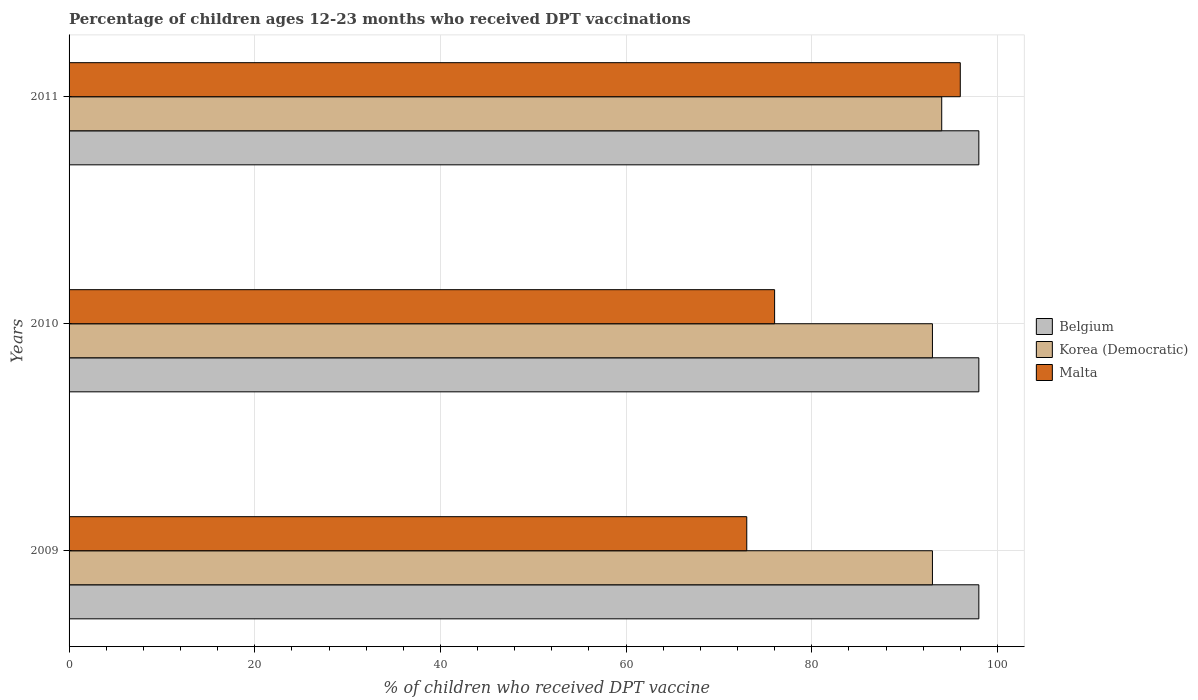How many different coloured bars are there?
Give a very brief answer. 3. How many groups of bars are there?
Offer a very short reply. 3. Are the number of bars per tick equal to the number of legend labels?
Ensure brevity in your answer.  Yes. How many bars are there on the 3rd tick from the bottom?
Make the answer very short. 3. What is the label of the 1st group of bars from the top?
Offer a very short reply. 2011. Across all years, what is the maximum percentage of children who received DPT vaccination in Malta?
Keep it short and to the point. 96. Across all years, what is the minimum percentage of children who received DPT vaccination in Belgium?
Give a very brief answer. 98. In which year was the percentage of children who received DPT vaccination in Belgium maximum?
Offer a very short reply. 2009. What is the total percentage of children who received DPT vaccination in Malta in the graph?
Give a very brief answer. 245. What is the difference between the percentage of children who received DPT vaccination in Belgium in 2010 and the percentage of children who received DPT vaccination in Korea (Democratic) in 2009?
Provide a succinct answer. 5. In the year 2010, what is the difference between the percentage of children who received DPT vaccination in Malta and percentage of children who received DPT vaccination in Belgium?
Your response must be concise. -22. What is the ratio of the percentage of children who received DPT vaccination in Malta in 2009 to that in 2011?
Provide a short and direct response. 0.76. What is the difference between the highest and the lowest percentage of children who received DPT vaccination in Belgium?
Provide a succinct answer. 0. In how many years, is the percentage of children who received DPT vaccination in Korea (Democratic) greater than the average percentage of children who received DPT vaccination in Korea (Democratic) taken over all years?
Ensure brevity in your answer.  1. What does the 2nd bar from the top in 2011 represents?
Your answer should be compact. Korea (Democratic). What does the 3rd bar from the bottom in 2010 represents?
Offer a very short reply. Malta. Is it the case that in every year, the sum of the percentage of children who received DPT vaccination in Belgium and percentage of children who received DPT vaccination in Korea (Democratic) is greater than the percentage of children who received DPT vaccination in Malta?
Your answer should be compact. Yes. How many bars are there?
Make the answer very short. 9. Are all the bars in the graph horizontal?
Offer a terse response. Yes. How many years are there in the graph?
Offer a terse response. 3. Does the graph contain grids?
Provide a short and direct response. Yes. Where does the legend appear in the graph?
Offer a very short reply. Center right. How many legend labels are there?
Provide a succinct answer. 3. How are the legend labels stacked?
Give a very brief answer. Vertical. What is the title of the graph?
Your response must be concise. Percentage of children ages 12-23 months who received DPT vaccinations. What is the label or title of the X-axis?
Provide a succinct answer. % of children who received DPT vaccine. What is the label or title of the Y-axis?
Your response must be concise. Years. What is the % of children who received DPT vaccine in Belgium in 2009?
Your answer should be compact. 98. What is the % of children who received DPT vaccine in Korea (Democratic) in 2009?
Your answer should be compact. 93. What is the % of children who received DPT vaccine in Belgium in 2010?
Offer a terse response. 98. What is the % of children who received DPT vaccine in Korea (Democratic) in 2010?
Keep it short and to the point. 93. What is the % of children who received DPT vaccine of Korea (Democratic) in 2011?
Offer a terse response. 94. What is the % of children who received DPT vaccine of Malta in 2011?
Provide a short and direct response. 96. Across all years, what is the maximum % of children who received DPT vaccine of Korea (Democratic)?
Provide a succinct answer. 94. Across all years, what is the maximum % of children who received DPT vaccine of Malta?
Your answer should be very brief. 96. Across all years, what is the minimum % of children who received DPT vaccine of Belgium?
Offer a terse response. 98. Across all years, what is the minimum % of children who received DPT vaccine of Korea (Democratic)?
Offer a very short reply. 93. What is the total % of children who received DPT vaccine of Belgium in the graph?
Provide a succinct answer. 294. What is the total % of children who received DPT vaccine in Korea (Democratic) in the graph?
Provide a succinct answer. 280. What is the total % of children who received DPT vaccine of Malta in the graph?
Your answer should be very brief. 245. What is the difference between the % of children who received DPT vaccine in Korea (Democratic) in 2009 and that in 2010?
Offer a very short reply. 0. What is the difference between the % of children who received DPT vaccine of Malta in 2009 and that in 2010?
Your response must be concise. -3. What is the difference between the % of children who received DPT vaccine in Belgium in 2009 and that in 2011?
Give a very brief answer. 0. What is the difference between the % of children who received DPT vaccine of Korea (Democratic) in 2009 and that in 2011?
Provide a short and direct response. -1. What is the difference between the % of children who received DPT vaccine of Malta in 2009 and that in 2011?
Keep it short and to the point. -23. What is the difference between the % of children who received DPT vaccine of Malta in 2010 and that in 2011?
Your answer should be compact. -20. What is the difference between the % of children who received DPT vaccine in Korea (Democratic) in 2009 and the % of children who received DPT vaccine in Malta in 2010?
Your answer should be compact. 17. What is the difference between the % of children who received DPT vaccine of Belgium in 2009 and the % of children who received DPT vaccine of Korea (Democratic) in 2011?
Make the answer very short. 4. What is the difference between the % of children who received DPT vaccine of Belgium in 2009 and the % of children who received DPT vaccine of Malta in 2011?
Provide a short and direct response. 2. What is the difference between the % of children who received DPT vaccine of Belgium in 2010 and the % of children who received DPT vaccine of Korea (Democratic) in 2011?
Provide a succinct answer. 4. What is the average % of children who received DPT vaccine of Korea (Democratic) per year?
Your response must be concise. 93.33. What is the average % of children who received DPT vaccine in Malta per year?
Your response must be concise. 81.67. In the year 2010, what is the difference between the % of children who received DPT vaccine of Belgium and % of children who received DPT vaccine of Malta?
Offer a very short reply. 22. In the year 2010, what is the difference between the % of children who received DPT vaccine of Korea (Democratic) and % of children who received DPT vaccine of Malta?
Your answer should be compact. 17. What is the ratio of the % of children who received DPT vaccine in Belgium in 2009 to that in 2010?
Ensure brevity in your answer.  1. What is the ratio of the % of children who received DPT vaccine of Korea (Democratic) in 2009 to that in 2010?
Offer a very short reply. 1. What is the ratio of the % of children who received DPT vaccine in Malta in 2009 to that in 2010?
Give a very brief answer. 0.96. What is the ratio of the % of children who received DPT vaccine in Malta in 2009 to that in 2011?
Offer a very short reply. 0.76. What is the ratio of the % of children who received DPT vaccine of Belgium in 2010 to that in 2011?
Provide a succinct answer. 1. What is the ratio of the % of children who received DPT vaccine of Malta in 2010 to that in 2011?
Your answer should be compact. 0.79. What is the difference between the highest and the second highest % of children who received DPT vaccine in Belgium?
Your answer should be very brief. 0. What is the difference between the highest and the second highest % of children who received DPT vaccine in Malta?
Your answer should be very brief. 20. What is the difference between the highest and the lowest % of children who received DPT vaccine of Korea (Democratic)?
Provide a short and direct response. 1. 